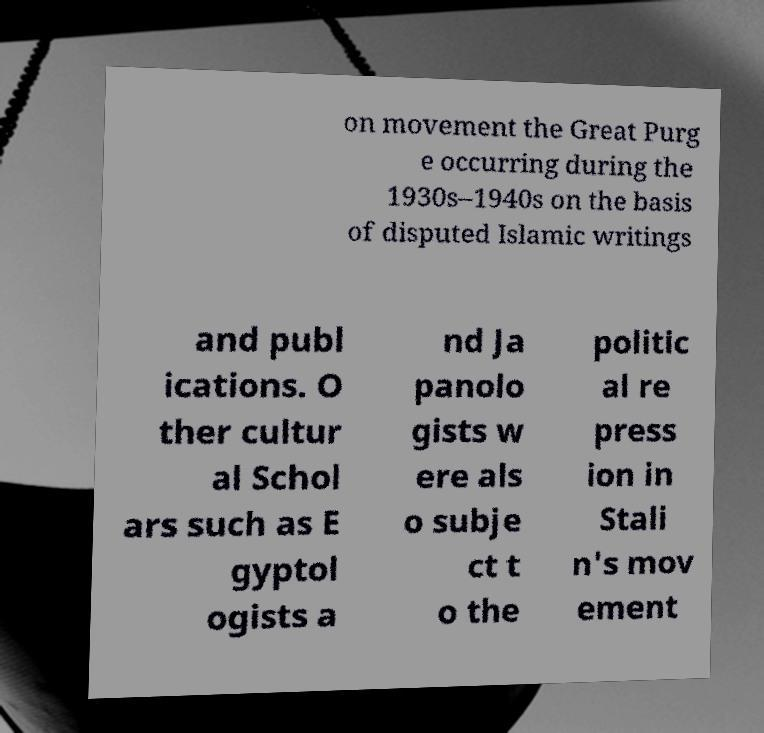What role did cultural scholars like Egyptologists play during the Stalin era? Under Stalin's regime, many cultural scholars, including Egyptologists and other specialists in non-Russian cultures, were scrutinized or repressed. Their work was often seen as a threat to the nationalist narrative Stalin promoted, which primarily focused on Russian history and culture. Scholars could be targeted for their international connections, perceived disloyalty, or simply because their work did not align with government propaganda. 